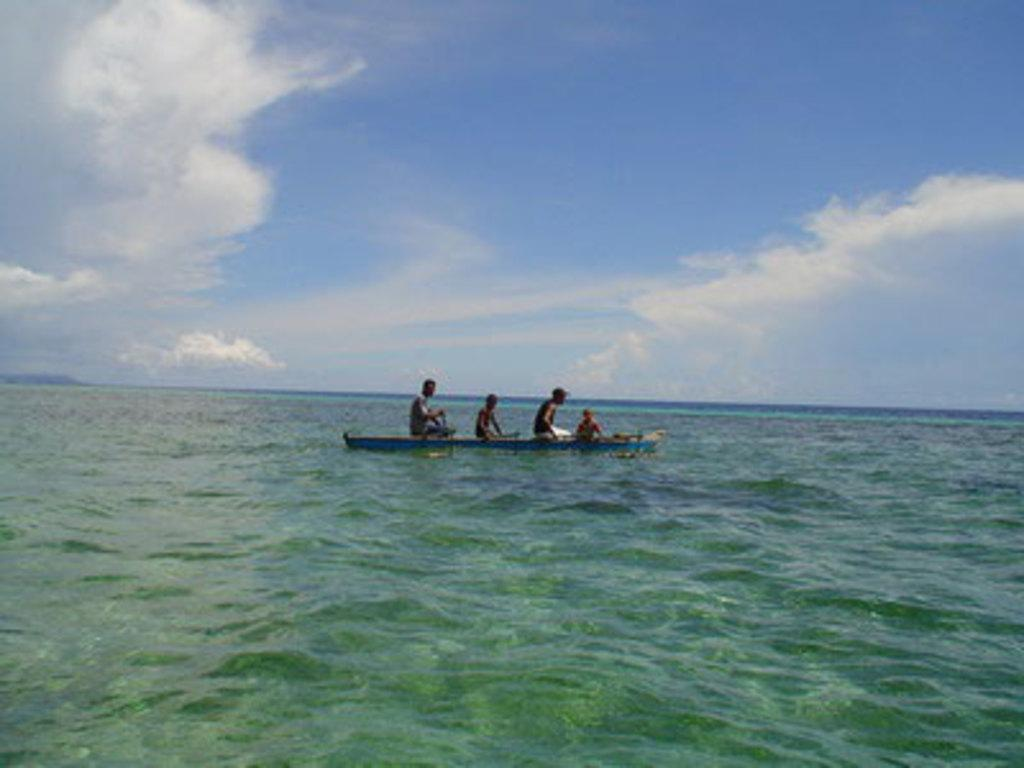What are the people in the image doing? The people in the image are sitting in a boat. Where is the boat located? The boat is on the water. What type of punishment is being administered to the farmer in the image? There is no farmer or punishment present in the image; it features persons sitting in a boat on the water. 